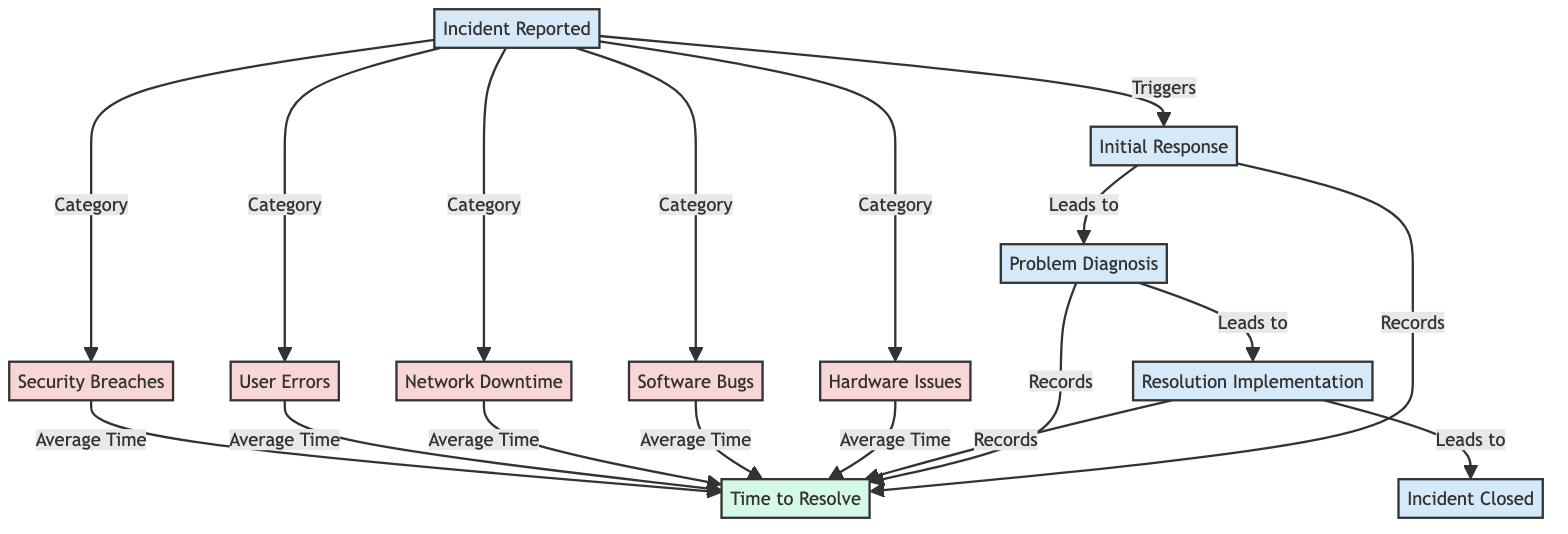What are the five incident types listed in the diagram? The diagram explicitly shows five types of incidents: Hardware Issues, Software Bugs, Network Downtime, User Errors, and Security Breaches. This is directly observable from the nodes designated for incident types.
Answer: Hardware Issues, Software Bugs, Network Downtime, User Errors, Security Breaches What is the first step after an incident is reported? The flowchart indicates that the first step following an incident report is the Initial Response. This is the first process node that occurs after the incident is reported.
Answer: Initial Response How many processes are involved in the incident management flow? The diagram contains a total of five process nodes: Incident Reported, Initial Response, Problem Diagnosis, Resolution Implementation, and Incident Closed. Simply count the process nodes to get this number.
Answer: 5 What leads to the implementation of resolution? The flowchart shows that Problem Diagnosis leads to Resolution Implementation. This directional arrow visually represents the flow from one process to the next in the incident management framework.
Answer: Problem Diagnosis What is recorded during the resolution process? The diagram notes that Time to Resolve is recorded during the phases of Initial Response, Problem Diagnosis, and Resolution Implementation. Each of these processes contributes to logging the total time taken to resolve the incident.
Answer: Time to Resolve Which incident type is associated with the average time metric? The diagram indicates that the average time is associated with all five incident types: Hardware Issues, Software Bugs, Network Downtime, User Errors, and Security Breaches. These incident types lead to the metric of average time.
Answer: Hardware Issues, Software Bugs, Network Downtime, User Errors, Security Breaches What is the final step in the incident management process? The diagram shows that the final step in the incident management process is Incident Closed. This is indicated as the last process node in the flow, completing the incident response cycle.
Answer: Incident Closed How is the average time for incident types determined? The diagram implies that the average time is derived from the resolution times recorded for all categorized incident types. By averaging the time logged for each incident type, it provides a consolidated metric of resolution time across all incidents.
Answer: Average Time 